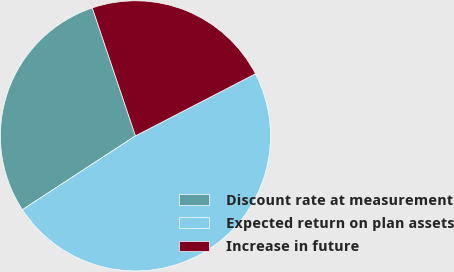Convert chart. <chart><loc_0><loc_0><loc_500><loc_500><pie_chart><fcel>Discount rate at measurement<fcel>Expected return on plan assets<fcel>Increase in future<nl><fcel>29.03%<fcel>48.39%<fcel>22.58%<nl></chart> 